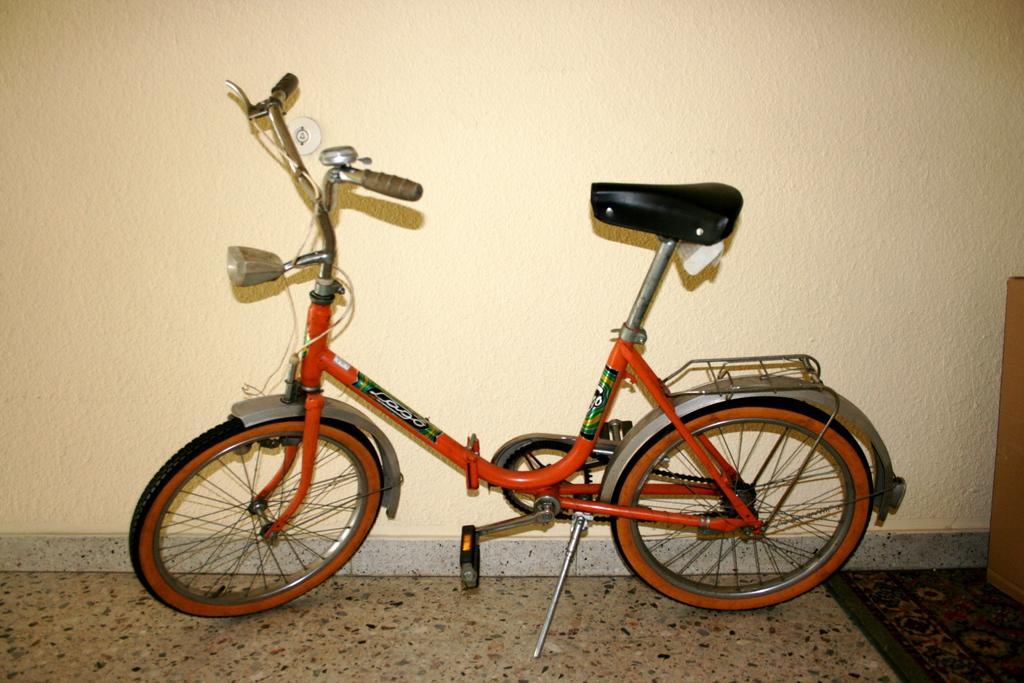In one or two sentences, can you explain what this image depicts? Here I can see a bicycle on the floor. At the back of it there is a wall. 